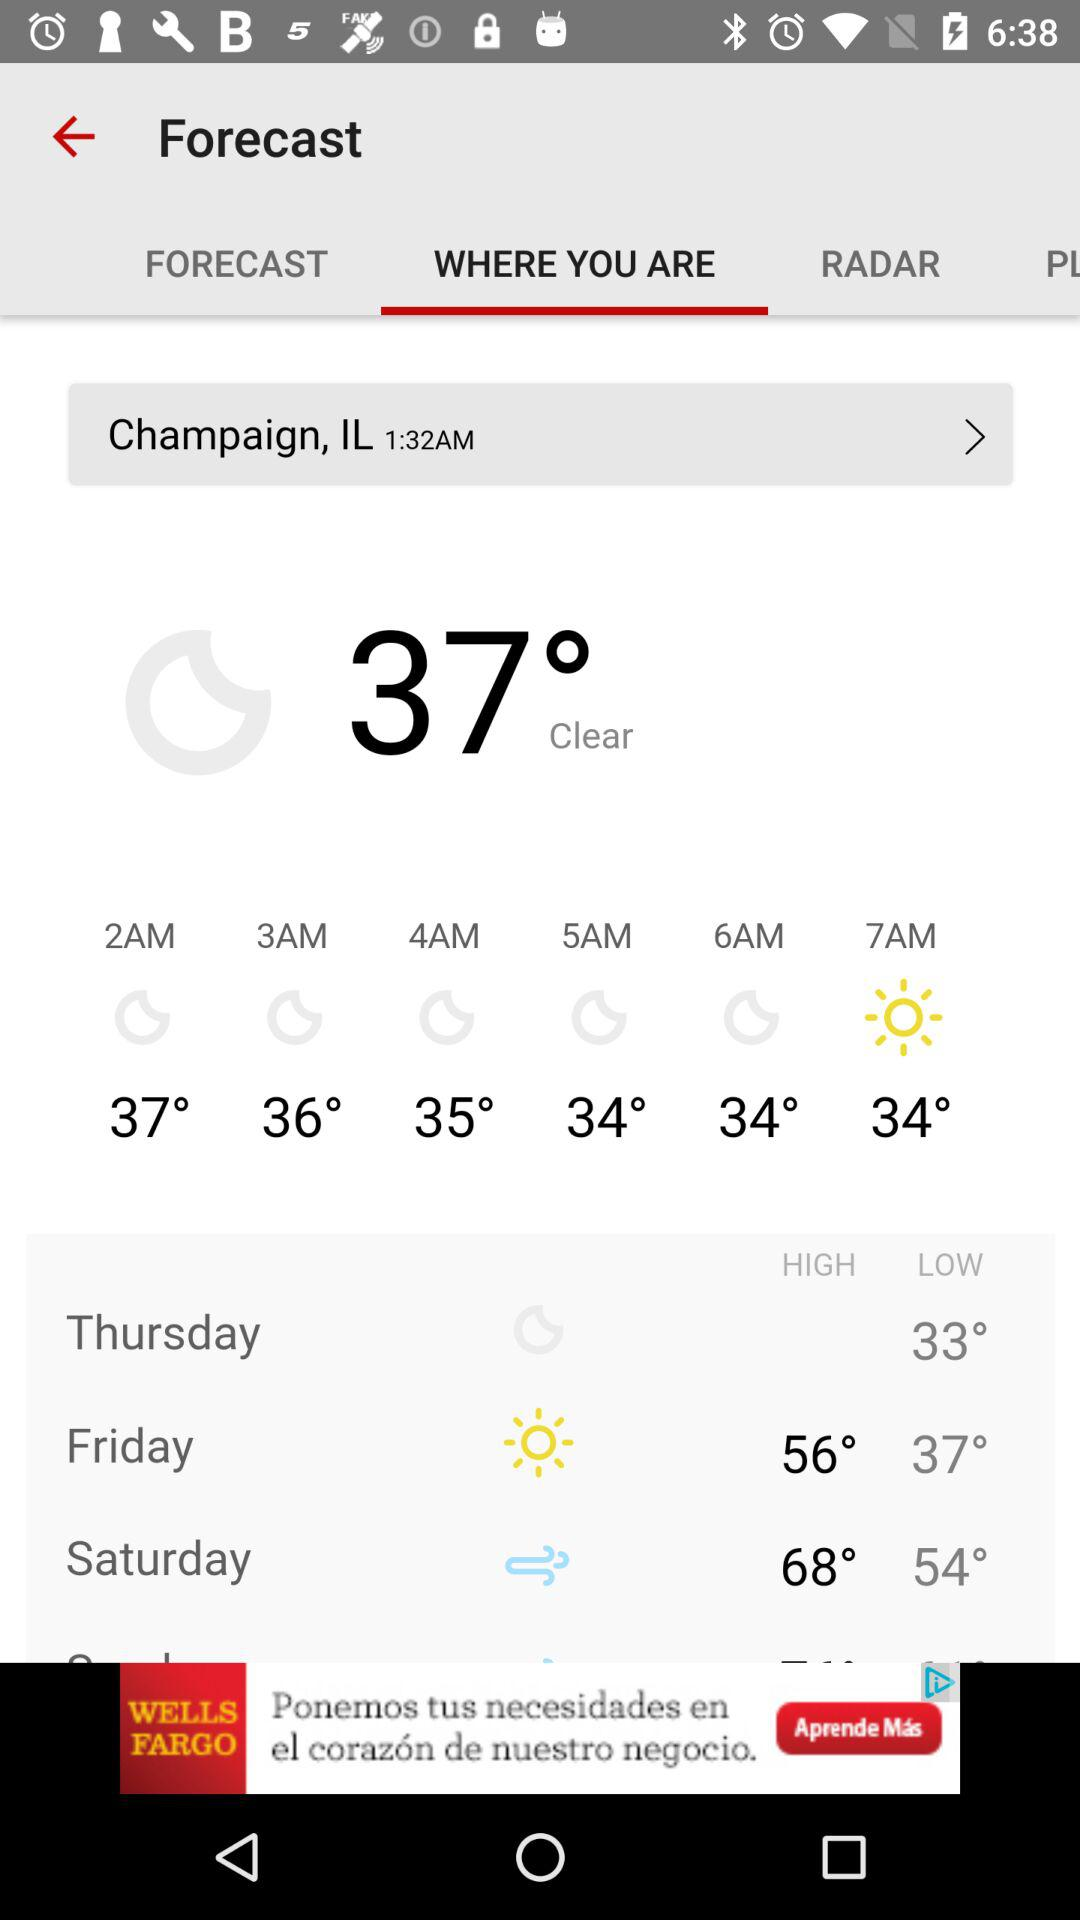What is the location? The location is Champaign, IL. 